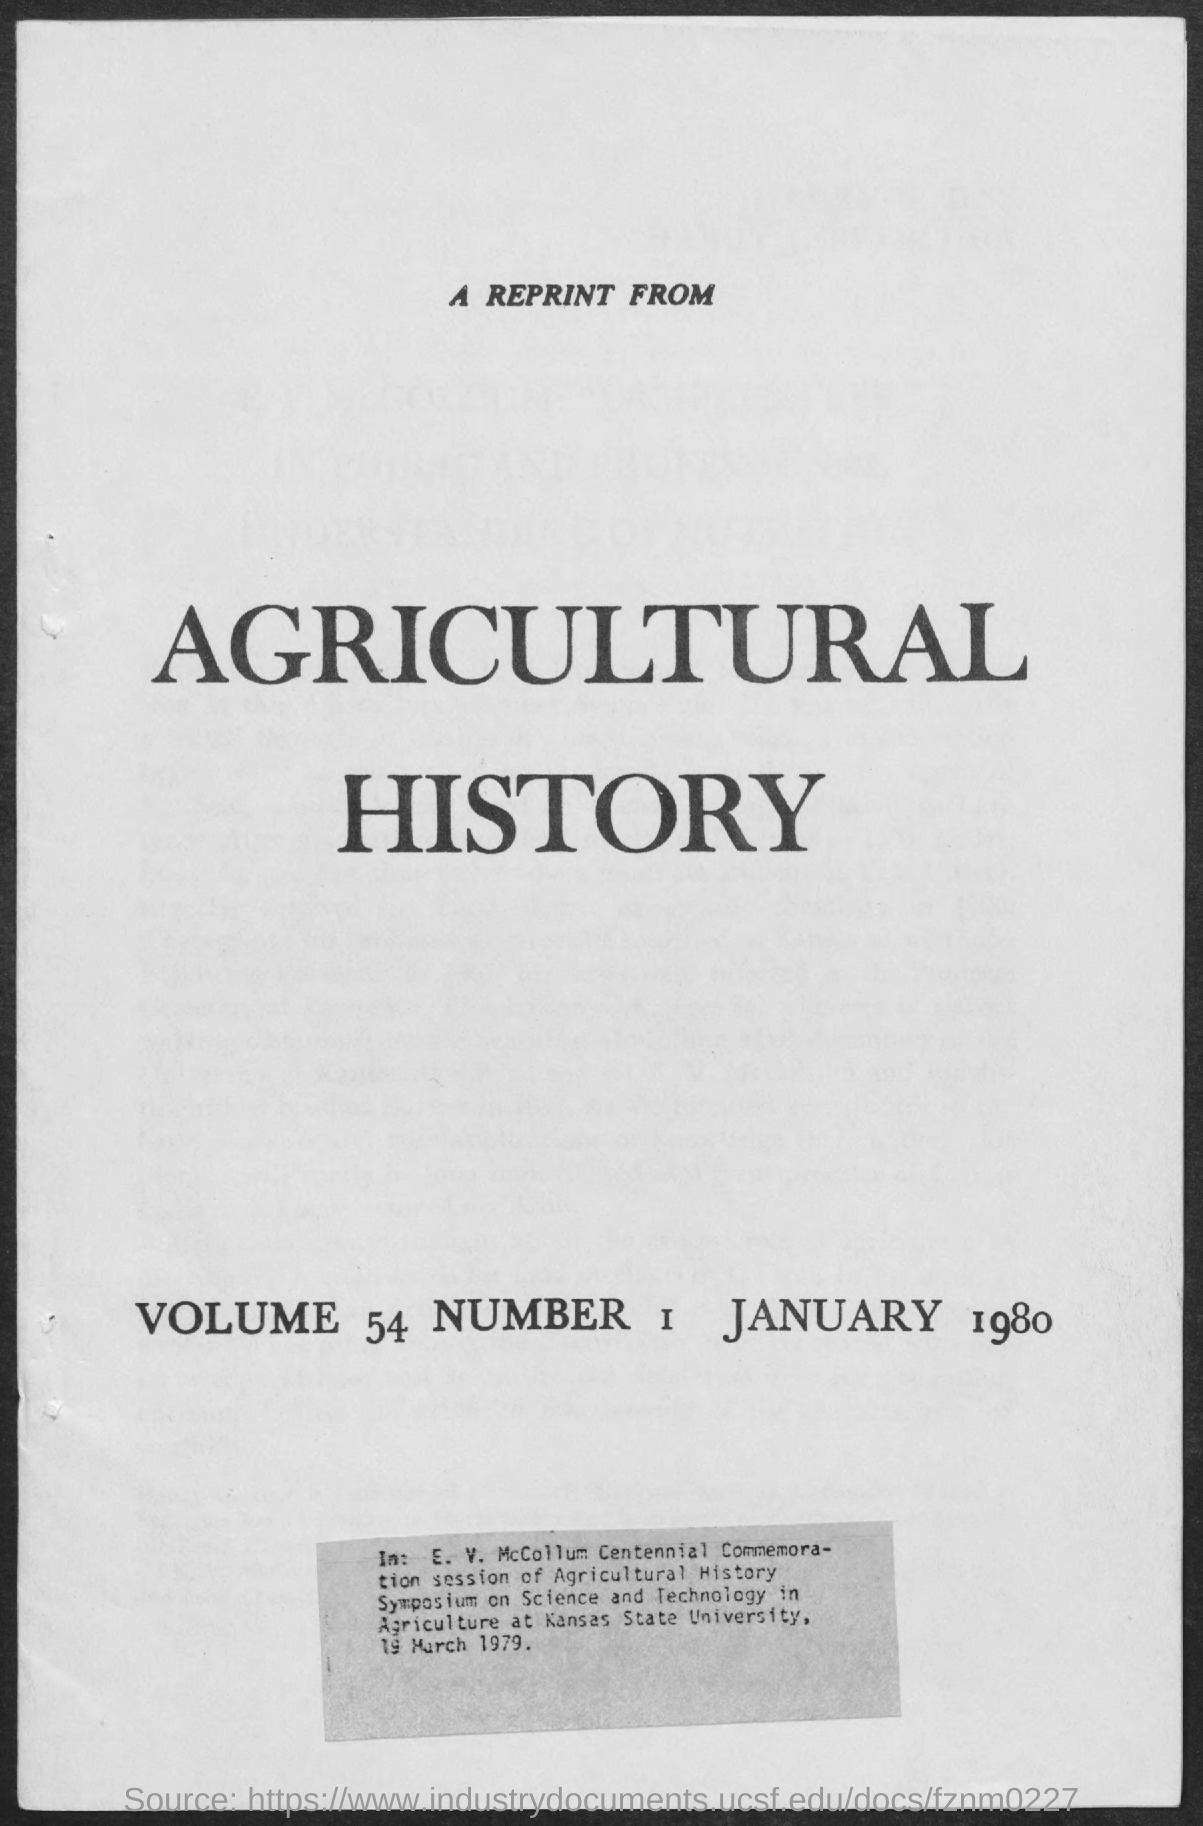What is the volume number mentioned ?
Offer a terse response. 54. What is the number mentioned ?
Your answer should be very brief. 1. What is the date mentioned ?
Make the answer very short. January 1980. What is the heading mentioned in the given form ?
Keep it short and to the point. Agricultural history. 